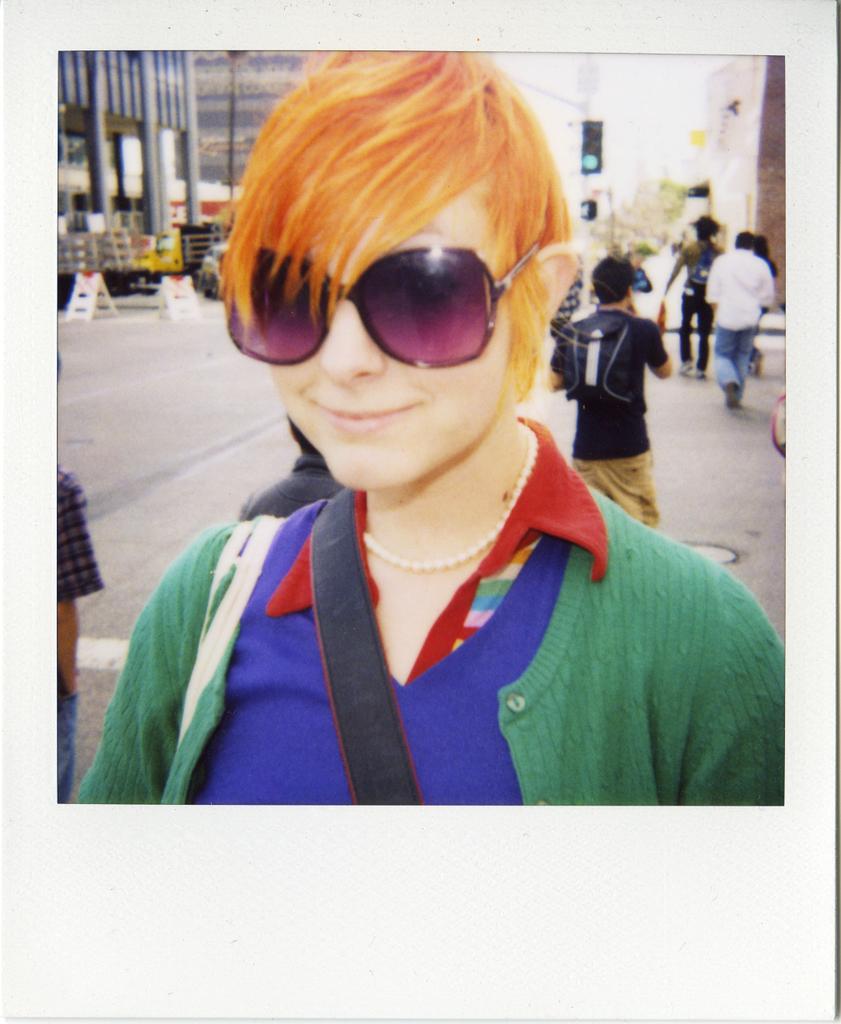Can you describe this image briefly? This image consists of a photograph. In this photo a woman is smiling, wearing a bag, goggles, jacket and giving pose for the picture. In the background few people walking on the road and there are few buildings. 